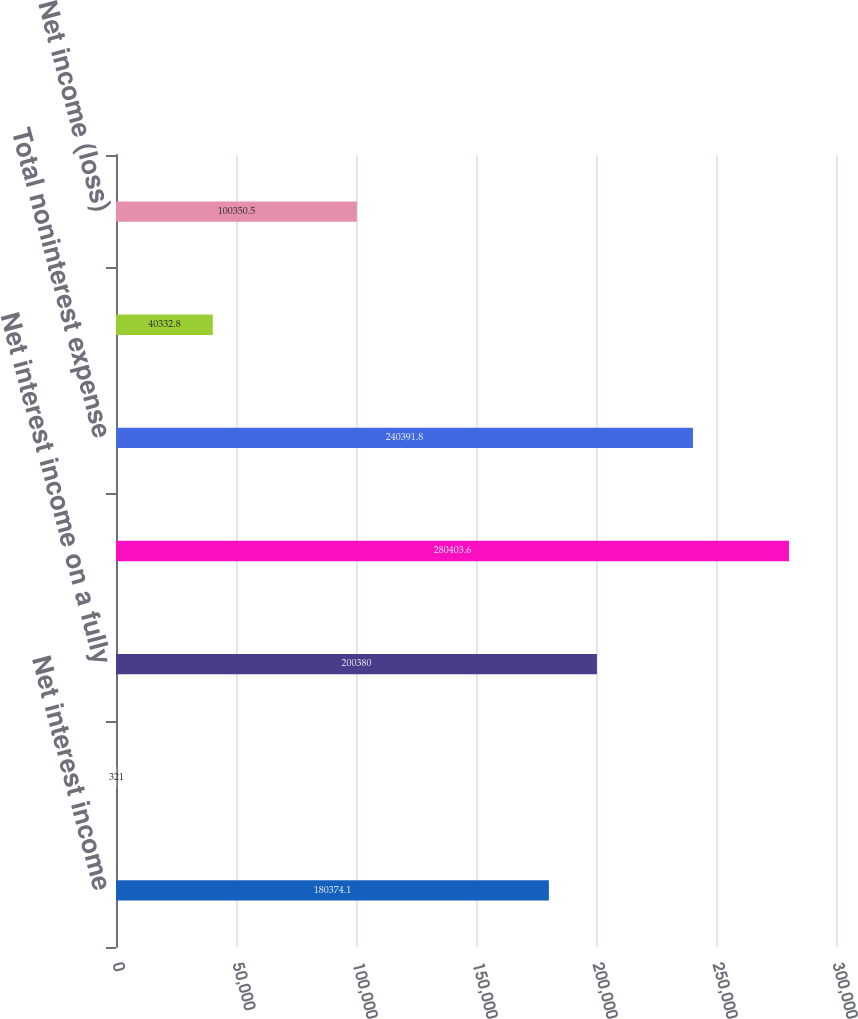Convert chart. <chart><loc_0><loc_0><loc_500><loc_500><bar_chart><fcel>Net interest income<fcel>Fully taxable-equivalent<fcel>Net interest income on a fully<fcel>Total revenue net of interest<fcel>Total noninterest expense<fcel>Income tax expense (benefit)<fcel>Net income (loss)<nl><fcel>180374<fcel>321<fcel>200380<fcel>280404<fcel>240392<fcel>40332.8<fcel>100350<nl></chart> 